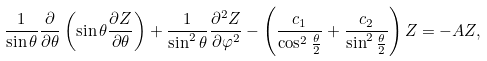Convert formula to latex. <formula><loc_0><loc_0><loc_500><loc_500>\frac { 1 } { \sin \theta } \frac { \partial } { \partial \theta } \left ( \sin \theta \frac { \partial Z } { \partial \theta } \right ) + \frac { 1 } { \sin ^ { 2 } \theta } \frac { \partial ^ { 2 } Z } { \partial \varphi ^ { 2 } } - \left ( \frac { c _ { 1 } } { \cos ^ { 2 } \frac { \theta } { 2 } } + \frac { c _ { 2 } } { \sin ^ { 2 } \frac { \theta } { 2 } } \right ) Z = - A Z ,</formula> 